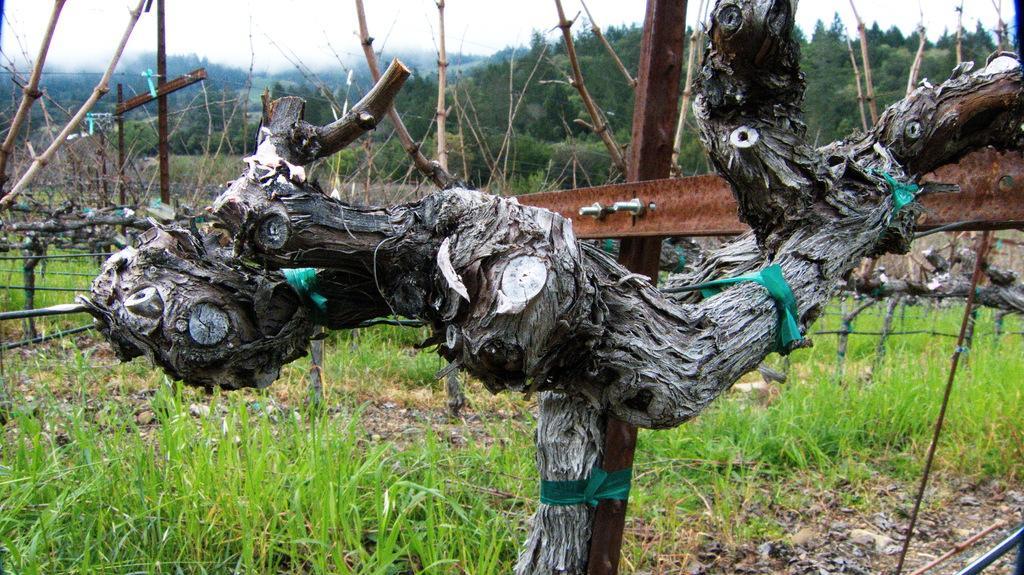Please provide a concise description of this image. In this picture I can see tree trunk, fencing, grass and trees. 